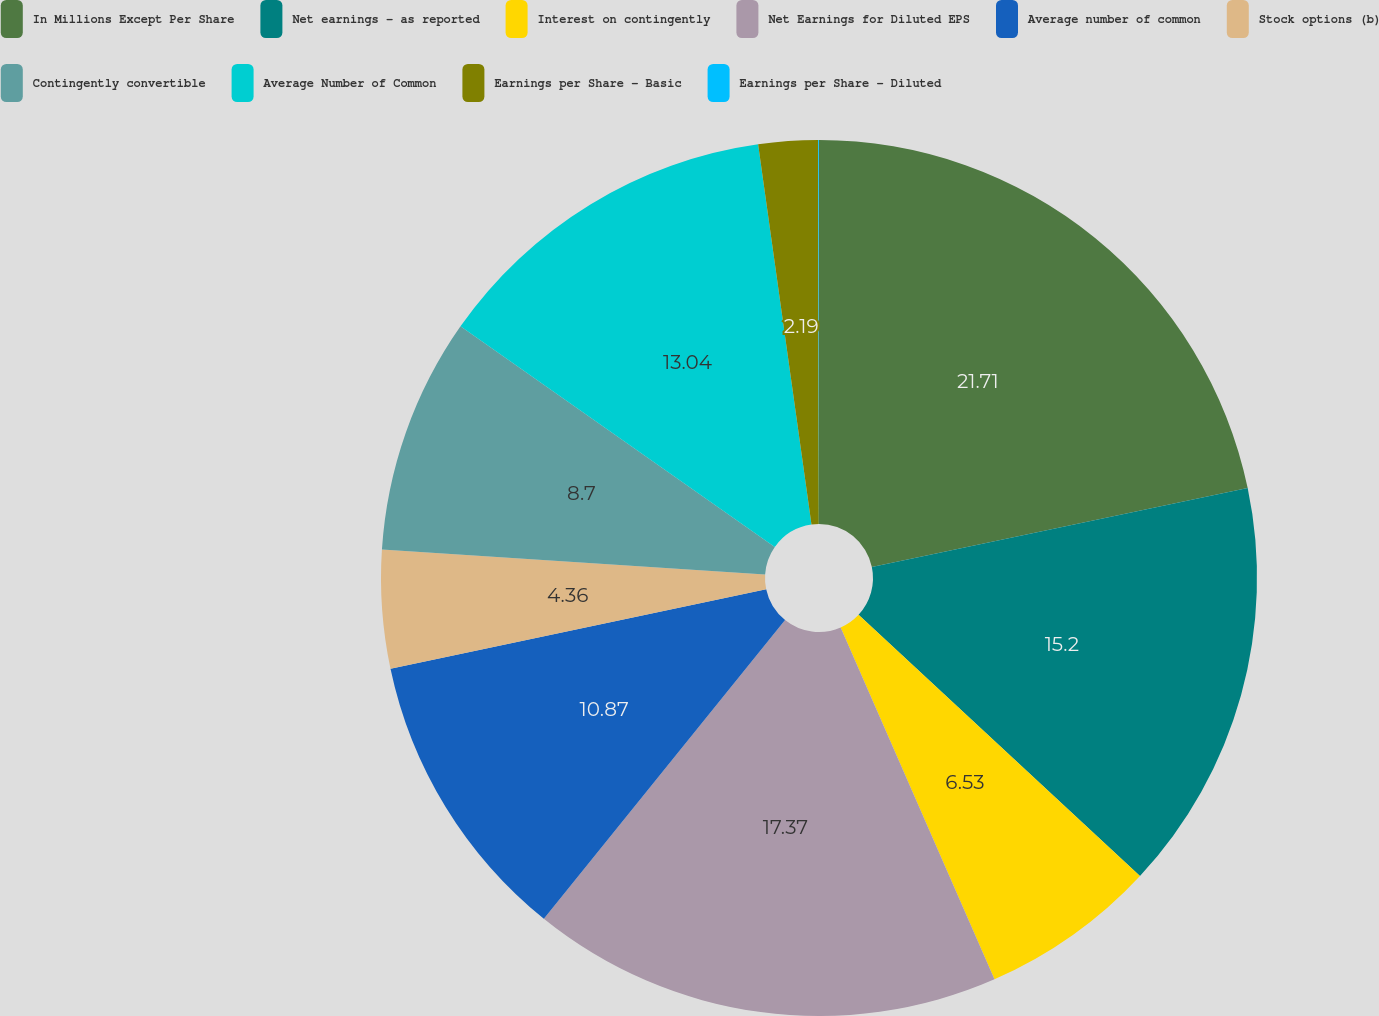<chart> <loc_0><loc_0><loc_500><loc_500><pie_chart><fcel>In Millions Except Per Share<fcel>Net earnings - as reported<fcel>Interest on contingently<fcel>Net Earnings for Diluted EPS<fcel>Average number of common<fcel>Stock options (b)<fcel>Contingently convertible<fcel>Average Number of Common<fcel>Earnings per Share - Basic<fcel>Earnings per Share - Diluted<nl><fcel>21.71%<fcel>15.2%<fcel>6.53%<fcel>17.37%<fcel>10.87%<fcel>4.36%<fcel>8.7%<fcel>13.04%<fcel>2.19%<fcel>0.03%<nl></chart> 